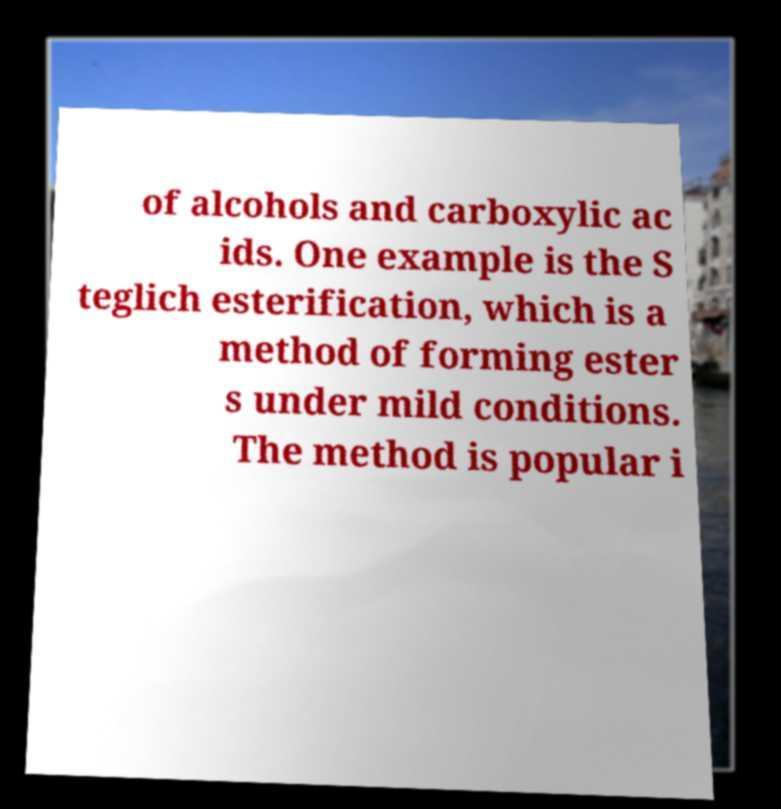What messages or text are displayed in this image? I need them in a readable, typed format. of alcohols and carboxylic ac ids. One example is the S teglich esterification, which is a method of forming ester s under mild conditions. The method is popular i 